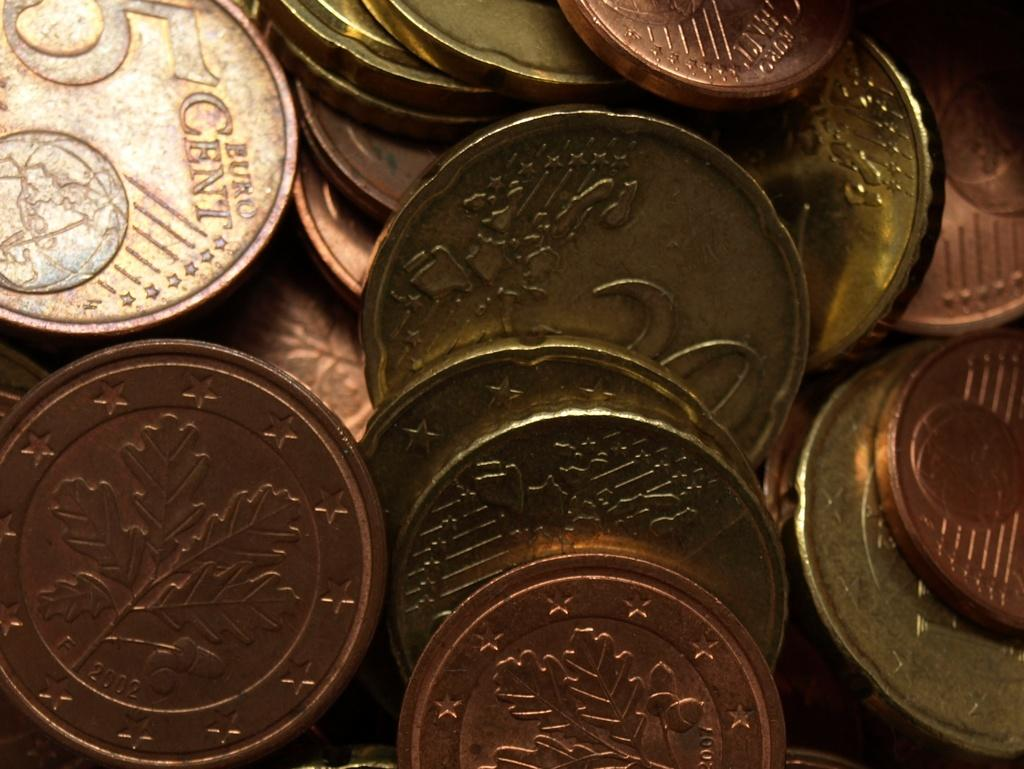<image>
Present a compact description of the photo's key features. coins of various denominations including a 5 cent euro. 